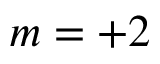Convert formula to latex. <formula><loc_0><loc_0><loc_500><loc_500>m = + 2</formula> 